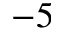<formula> <loc_0><loc_0><loc_500><loc_500>- 5</formula> 